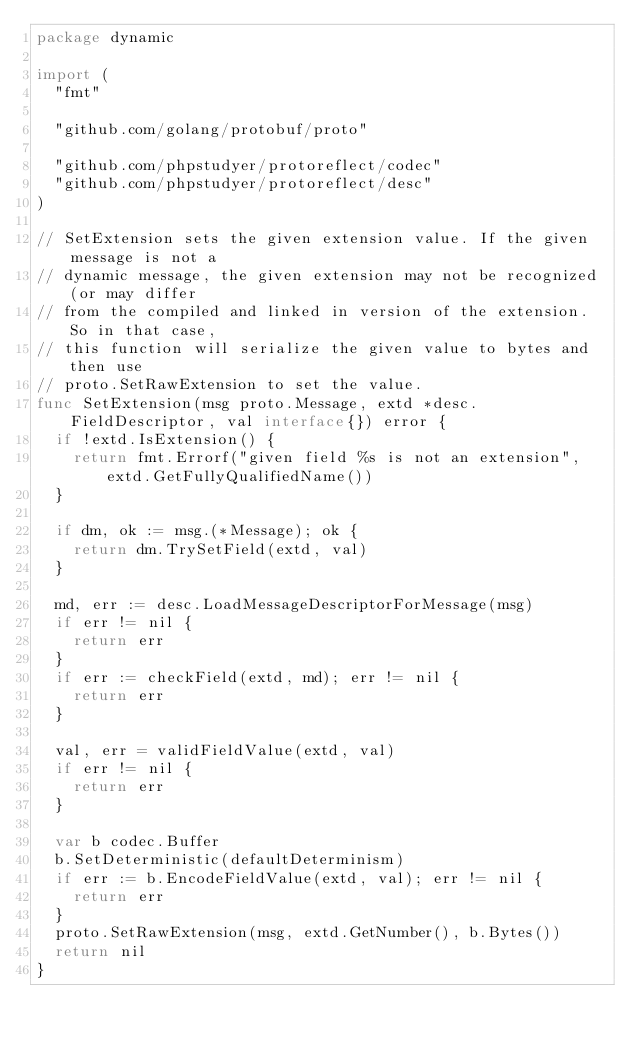<code> <loc_0><loc_0><loc_500><loc_500><_Go_>package dynamic

import (
	"fmt"

	"github.com/golang/protobuf/proto"

	"github.com/phpstudyer/protoreflect/codec"
	"github.com/phpstudyer/protoreflect/desc"
)

// SetExtension sets the given extension value. If the given message is not a
// dynamic message, the given extension may not be recognized (or may differ
// from the compiled and linked in version of the extension. So in that case,
// this function will serialize the given value to bytes and then use
// proto.SetRawExtension to set the value.
func SetExtension(msg proto.Message, extd *desc.FieldDescriptor, val interface{}) error {
	if !extd.IsExtension() {
		return fmt.Errorf("given field %s is not an extension", extd.GetFullyQualifiedName())
	}

	if dm, ok := msg.(*Message); ok {
		return dm.TrySetField(extd, val)
	}

	md, err := desc.LoadMessageDescriptorForMessage(msg)
	if err != nil {
		return err
	}
	if err := checkField(extd, md); err != nil {
		return err
	}

	val, err = validFieldValue(extd, val)
	if err != nil {
		return err
	}

	var b codec.Buffer
	b.SetDeterministic(defaultDeterminism)
	if err := b.EncodeFieldValue(extd, val); err != nil {
		return err
	}
	proto.SetRawExtension(msg, extd.GetNumber(), b.Bytes())
	return nil
}
</code> 